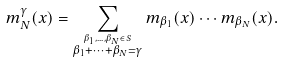<formula> <loc_0><loc_0><loc_500><loc_500>m _ { N } ^ { \gamma } ( x ) = \sum _ { \stackrel { \beta _ { 1 } , \dots , \beta _ { N } \in S } { \beta _ { 1 } + \cdots + \beta _ { N } = \gamma } } m _ { \beta _ { 1 } } ( x ) \cdots m _ { \beta _ { N } } ( x ) .</formula> 